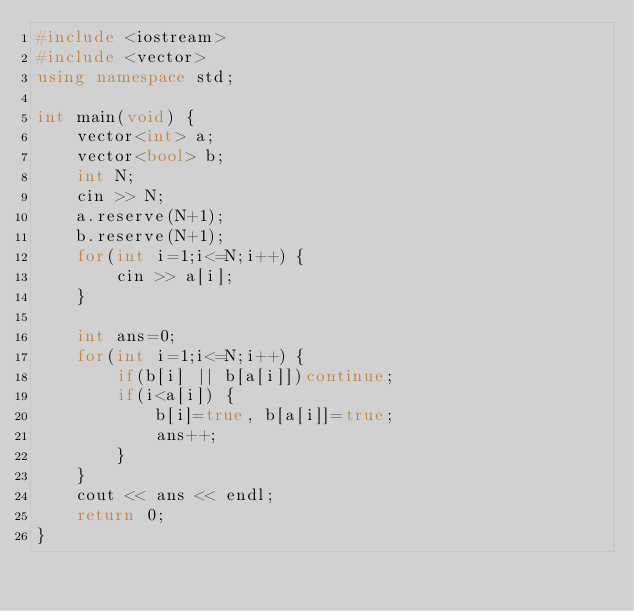<code> <loc_0><loc_0><loc_500><loc_500><_C++_>#include <iostream>
#include <vector>
using namespace std;

int main(void) {
    vector<int> a;
    vector<bool> b;
    int N;
    cin >> N;
    a.reserve(N+1);
    b.reserve(N+1);
    for(int i=1;i<=N;i++) {
        cin >> a[i];
    }

    int ans=0;
    for(int i=1;i<=N;i++) {
        if(b[i] || b[a[i]])continue;
        if(i<a[i]) {
            b[i]=true, b[a[i]]=true;
            ans++;
        }
    }
    cout << ans << endl;
    return 0;
}</code> 